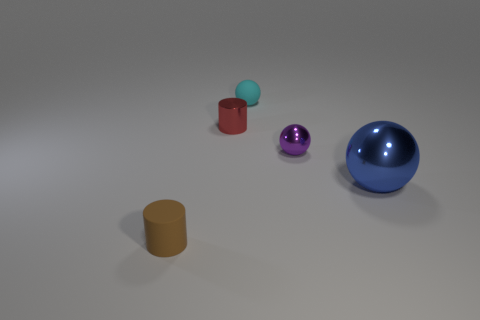Add 1 big blue objects. How many objects exist? 6 Subtract all balls. How many objects are left? 2 Subtract 1 brown cylinders. How many objects are left? 4 Subtract all tiny metallic things. Subtract all tiny brown matte cylinders. How many objects are left? 2 Add 3 purple things. How many purple things are left? 4 Add 1 metal cylinders. How many metal cylinders exist? 2 